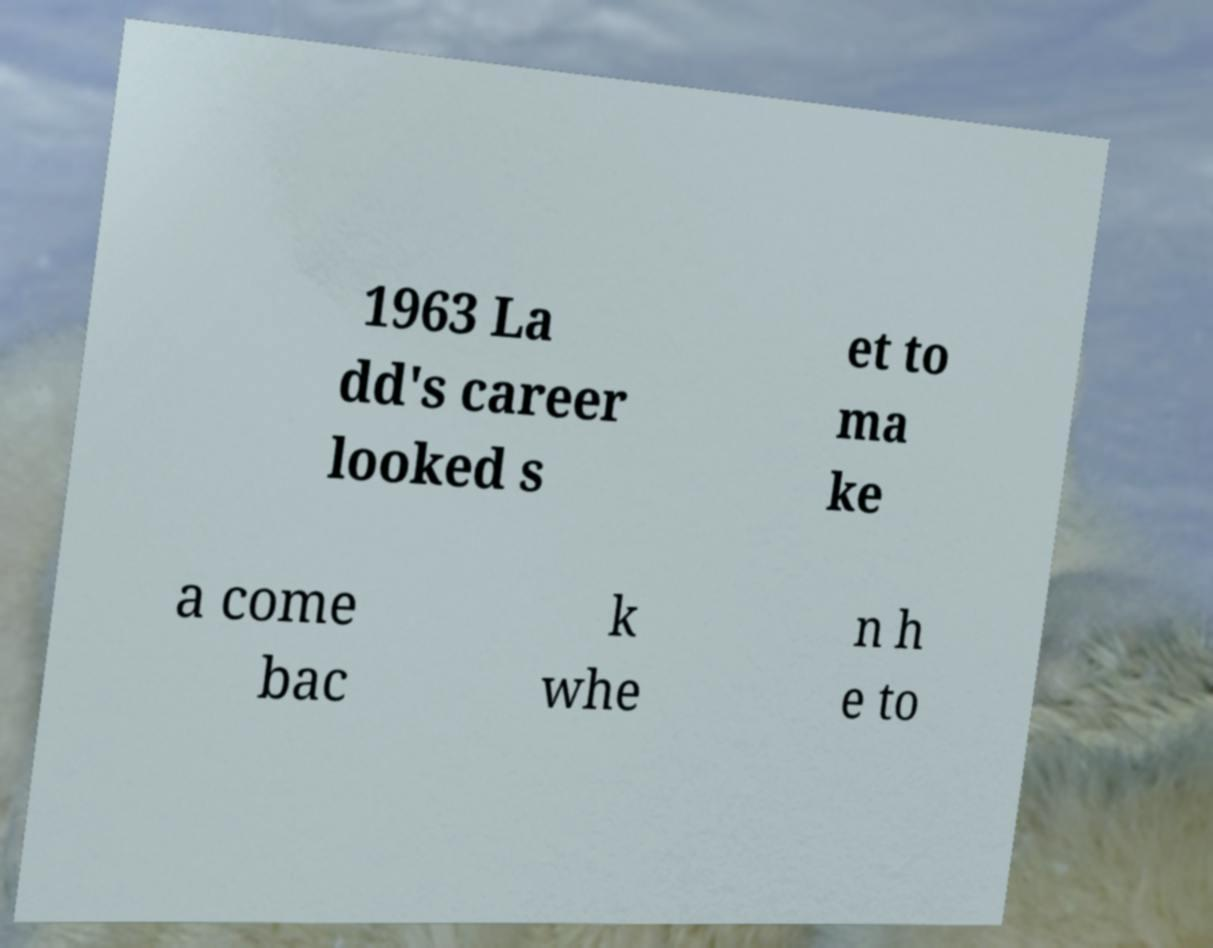For documentation purposes, I need the text within this image transcribed. Could you provide that? 1963 La dd's career looked s et to ma ke a come bac k whe n h e to 